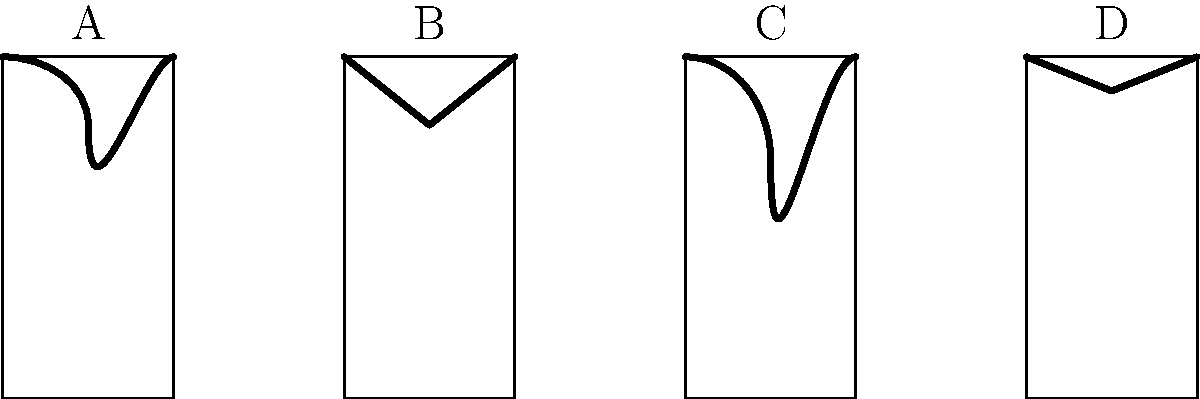As a fashion editor critiquing red carpet looks, you're often asked to identify neckline styles. In the diagram above, which letter corresponds to the sweetheart neckline, a style known for its romantic and feminine appeal? To identify the sweetheart neckline, let's analyze each neckline style presented in the diagram:

1. Neckline A: This shows a curved, scoop-like shape. It dips down in the center and curves up towards the shoulders. This is not a sweetheart neckline, but rather a scoop neckline.

2. Neckline B: This neckline forms a distinct heart shape at the bust. It has two curved edges that meet in a point at the center, creating a shape reminiscent of the top of a heart. This is the characteristic shape of a sweetheart neckline.

3. Neckline C: This neckline plunges deeply in a V-shape. While it has some curvature, it doesn't form the distinct heart shape of a sweetheart neckline. This is likely a plunging V-neckline.

4. Neckline D: This shows a straight line across the chest with slight dips at the shoulders. This is not a sweetheart neckline, but appears to be a straight or bateau neckline.

The sweetheart neckline, known for its romantic and feminine appeal, is characterized by its heart-shaped outline that resembles the top of a heart symbol. It typically dips low in the center and curves upwards towards the arms, creating two distinct peaks.

Based on this analysis, the neckline that best fits the description of a sweetheart neckline is option B.
Answer: B 